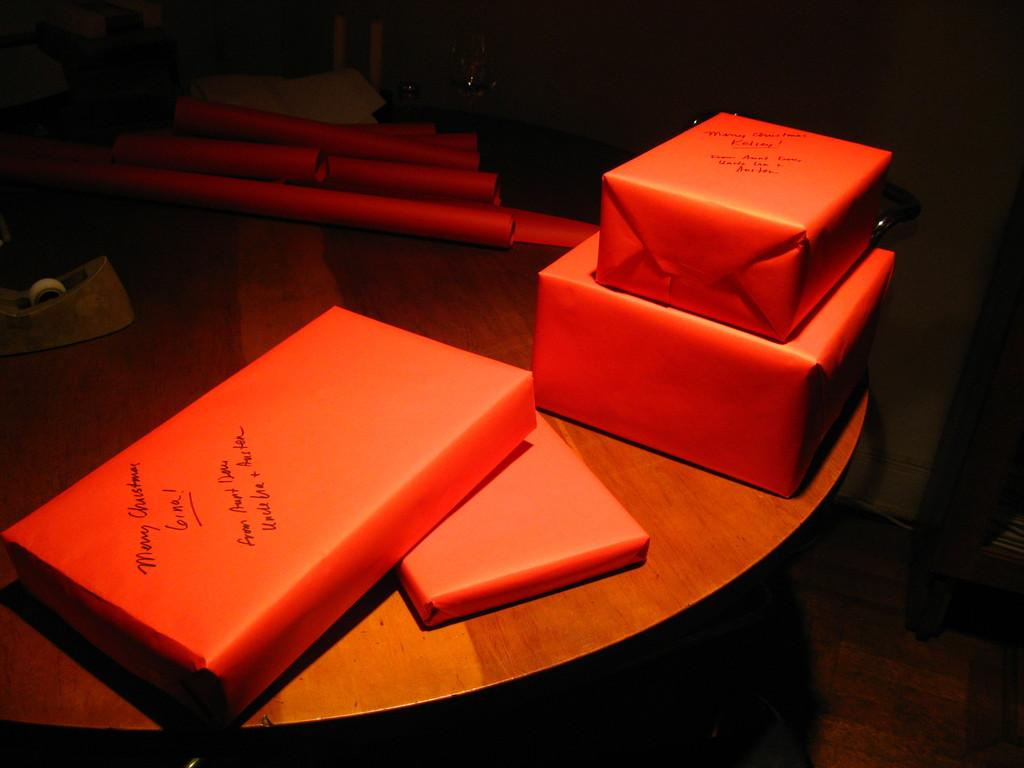Provide a one-sentence caption for the provided image. Orange presents with the message Merry Christmas written on them. 